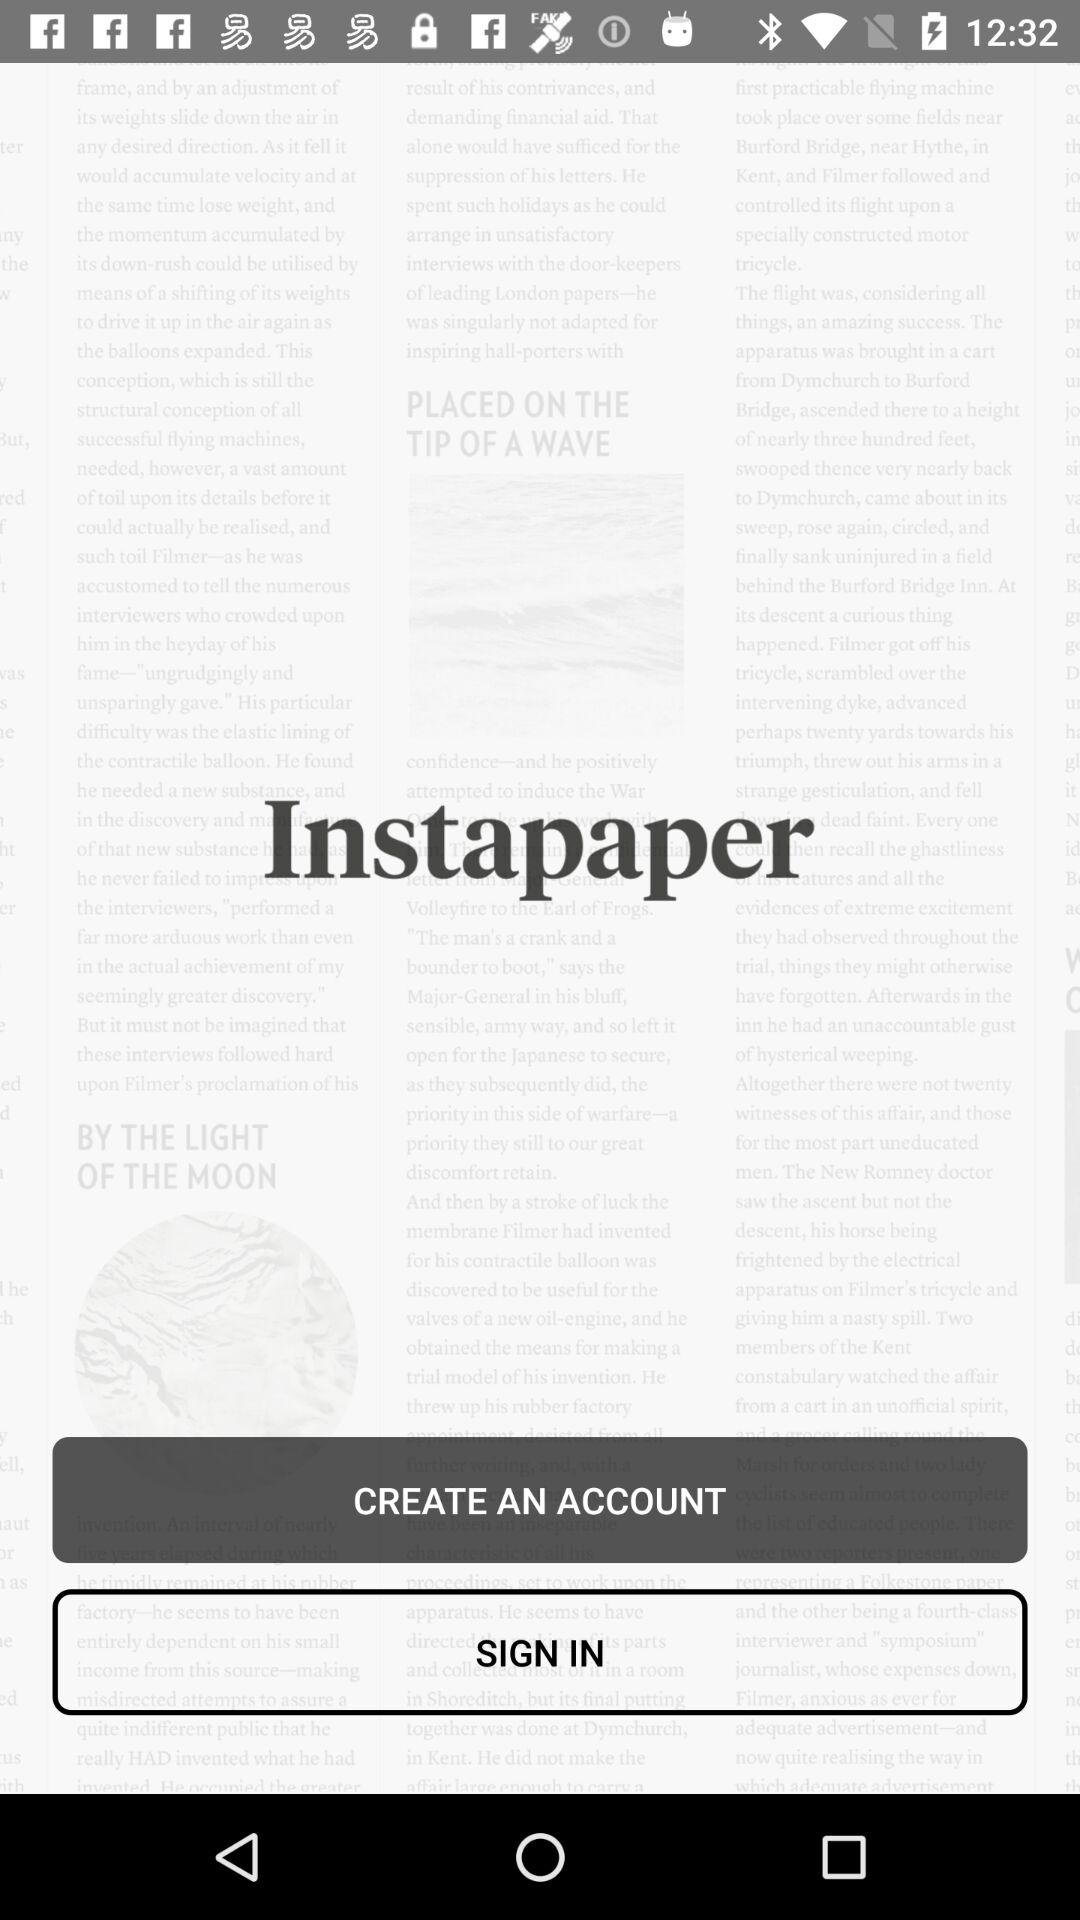What is the application name? The application name is "Instapaper". 